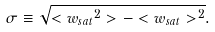<formula> <loc_0><loc_0><loc_500><loc_500>\sigma \equiv \sqrt { < { w _ { s a t } } ^ { 2 } > - < w _ { s a t } > ^ { 2 } } .</formula> 